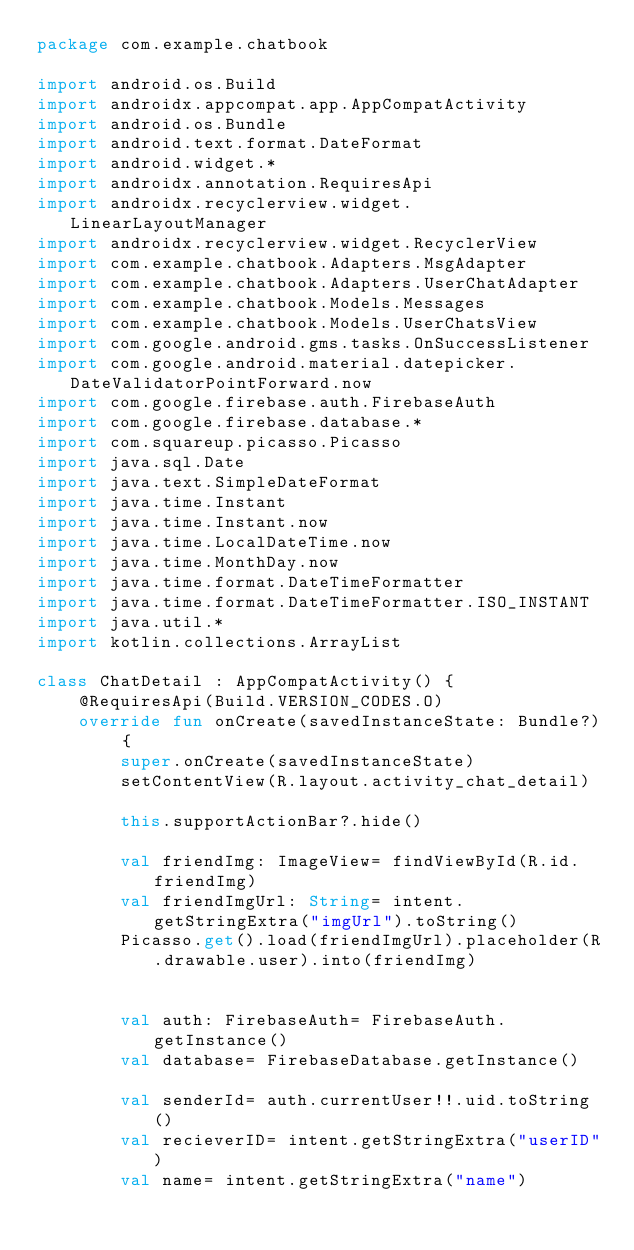Convert code to text. <code><loc_0><loc_0><loc_500><loc_500><_Kotlin_>package com.example.chatbook

import android.os.Build
import androidx.appcompat.app.AppCompatActivity
import android.os.Bundle
import android.text.format.DateFormat
import android.widget.*
import androidx.annotation.RequiresApi
import androidx.recyclerview.widget.LinearLayoutManager
import androidx.recyclerview.widget.RecyclerView
import com.example.chatbook.Adapters.MsgAdapter
import com.example.chatbook.Adapters.UserChatAdapter
import com.example.chatbook.Models.Messages
import com.example.chatbook.Models.UserChatsView
import com.google.android.gms.tasks.OnSuccessListener
import com.google.android.material.datepicker.DateValidatorPointForward.now
import com.google.firebase.auth.FirebaseAuth
import com.google.firebase.database.*
import com.squareup.picasso.Picasso
import java.sql.Date
import java.text.SimpleDateFormat
import java.time.Instant
import java.time.Instant.now
import java.time.LocalDateTime.now
import java.time.MonthDay.now
import java.time.format.DateTimeFormatter
import java.time.format.DateTimeFormatter.ISO_INSTANT
import java.util.*
import kotlin.collections.ArrayList

class ChatDetail : AppCompatActivity() {
    @RequiresApi(Build.VERSION_CODES.O)
    override fun onCreate(savedInstanceState: Bundle?) {
        super.onCreate(savedInstanceState)
        setContentView(R.layout.activity_chat_detail)

        this.supportActionBar?.hide()

        val friendImg: ImageView= findViewById(R.id.friendImg)
        val friendImgUrl: String= intent.getStringExtra("imgUrl").toString()
        Picasso.get().load(friendImgUrl).placeholder(R.drawable.user).into(friendImg)


        val auth: FirebaseAuth= FirebaseAuth.getInstance()
        val database= FirebaseDatabase.getInstance()

        val senderId= auth.currentUser!!.uid.toString()
        val recieverID= intent.getStringExtra("userID")
        val name= intent.getStringExtra("name")
</code> 